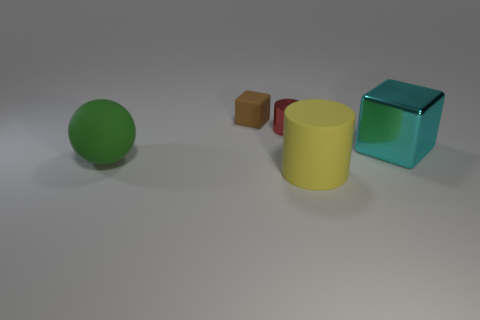Add 1 large green rubber objects. How many objects exist? 6 Subtract all spheres. How many objects are left? 4 Add 3 large yellow matte cylinders. How many large yellow matte cylinders exist? 4 Subtract 1 yellow cylinders. How many objects are left? 4 Subtract all tiny matte spheres. Subtract all big cyan shiny blocks. How many objects are left? 4 Add 2 big green rubber balls. How many big green rubber balls are left? 3 